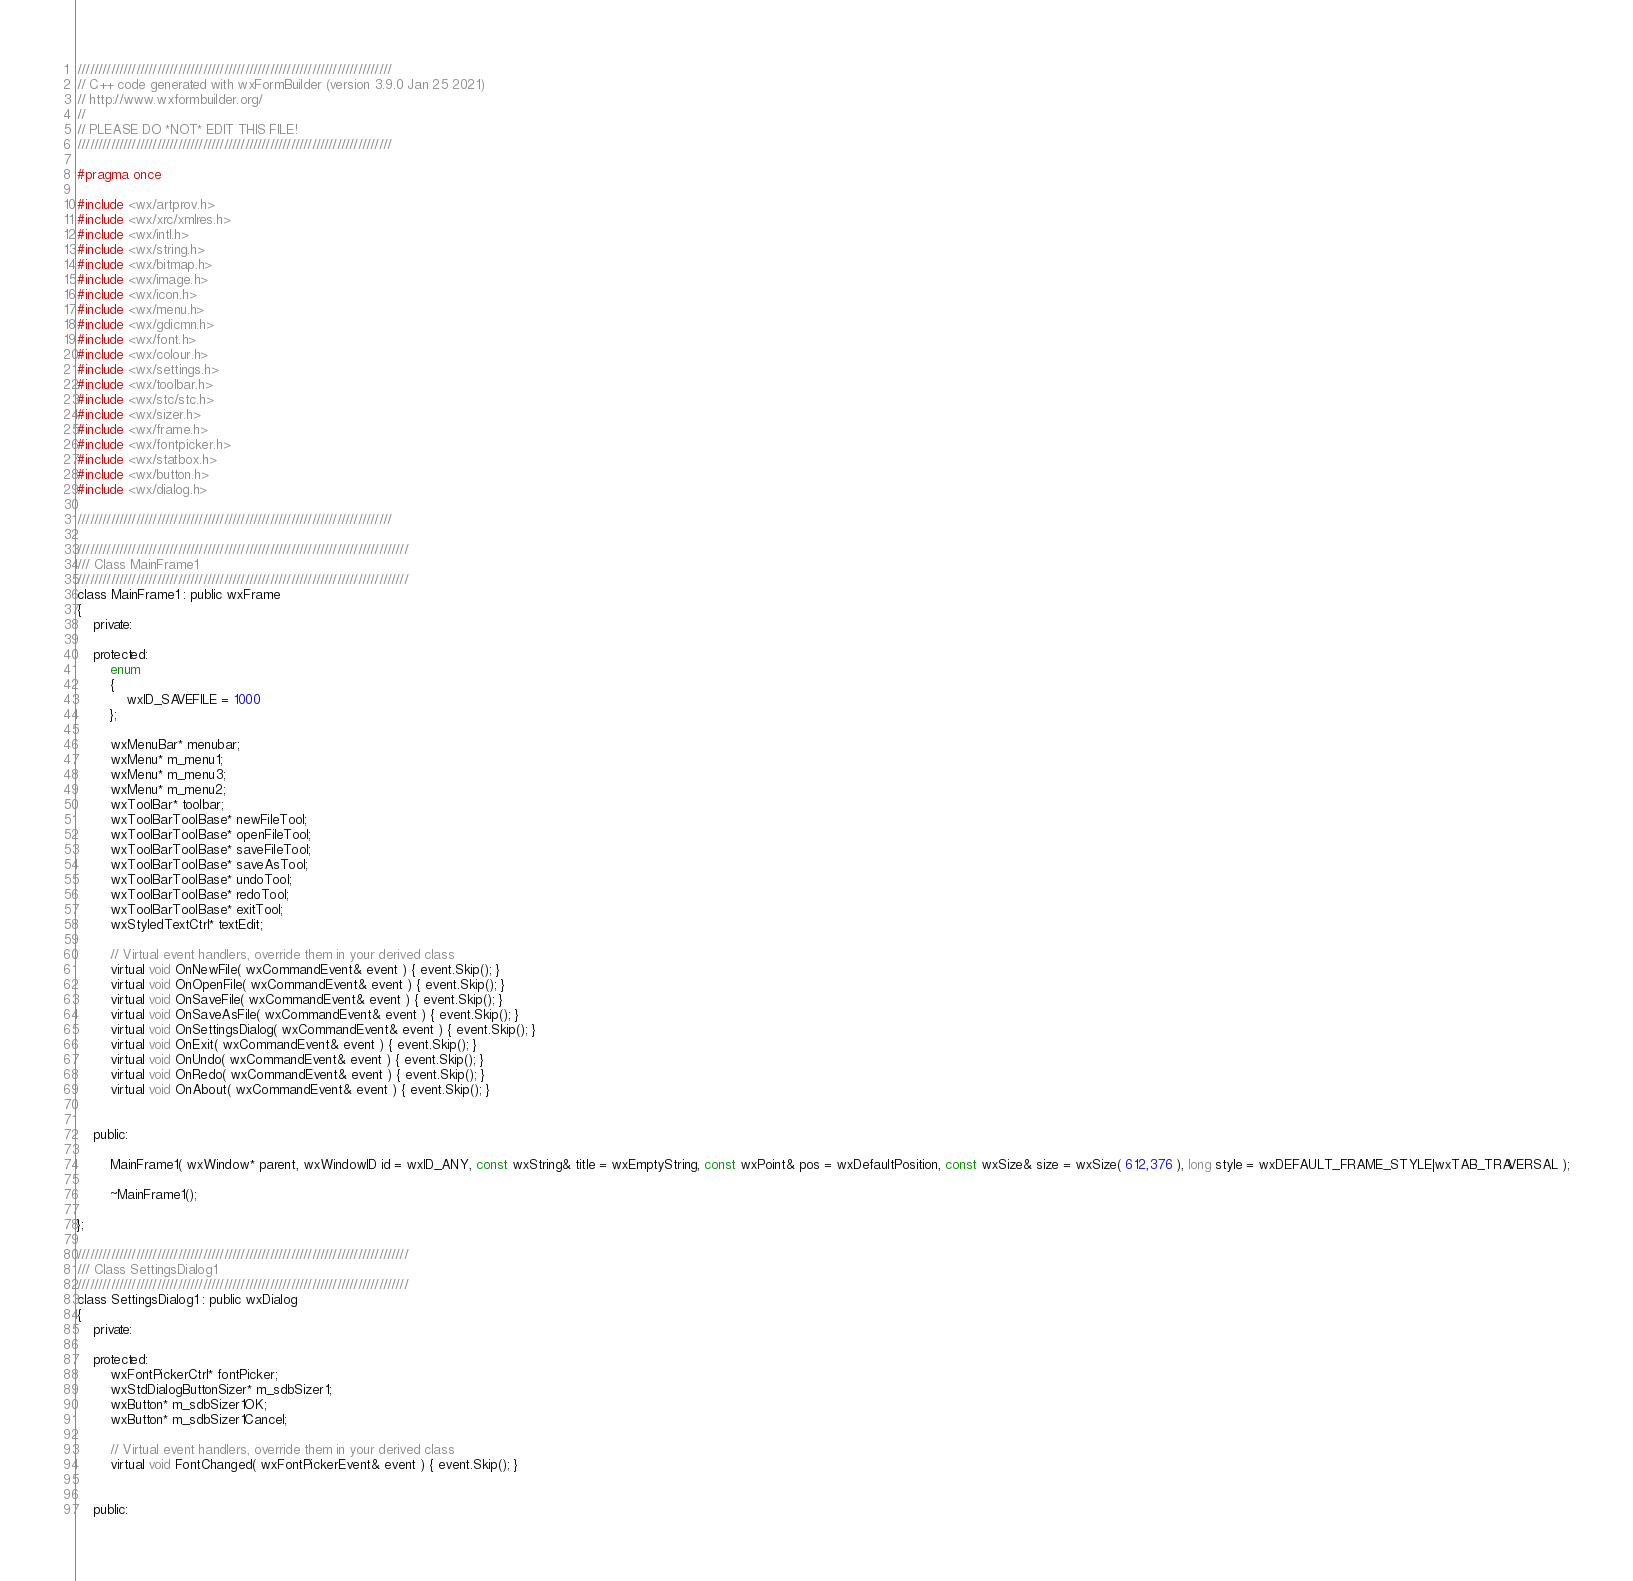Convert code to text. <code><loc_0><loc_0><loc_500><loc_500><_C_>///////////////////////////////////////////////////////////////////////////
// C++ code generated with wxFormBuilder (version 3.9.0 Jan 25 2021)
// http://www.wxformbuilder.org/
//
// PLEASE DO *NOT* EDIT THIS FILE!
///////////////////////////////////////////////////////////////////////////

#pragma once

#include <wx/artprov.h>
#include <wx/xrc/xmlres.h>
#include <wx/intl.h>
#include <wx/string.h>
#include <wx/bitmap.h>
#include <wx/image.h>
#include <wx/icon.h>
#include <wx/menu.h>
#include <wx/gdicmn.h>
#include <wx/font.h>
#include <wx/colour.h>
#include <wx/settings.h>
#include <wx/toolbar.h>
#include <wx/stc/stc.h>
#include <wx/sizer.h>
#include <wx/frame.h>
#include <wx/fontpicker.h>
#include <wx/statbox.h>
#include <wx/button.h>
#include <wx/dialog.h>

///////////////////////////////////////////////////////////////////////////

///////////////////////////////////////////////////////////////////////////////
/// Class MainFrame1
///////////////////////////////////////////////////////////////////////////////
class MainFrame1 : public wxFrame
{
	private:

	protected:
		enum
		{
			wxID_SAVEFILE = 1000
		};

		wxMenuBar* menubar;
		wxMenu* m_menu1;
		wxMenu* m_menu3;
		wxMenu* m_menu2;
		wxToolBar* toolbar;
		wxToolBarToolBase* newFileTool;
		wxToolBarToolBase* openFileTool;
		wxToolBarToolBase* saveFileTool;
		wxToolBarToolBase* saveAsTool;
		wxToolBarToolBase* undoTool;
		wxToolBarToolBase* redoTool;
		wxToolBarToolBase* exitTool;
		wxStyledTextCtrl* textEdit;

		// Virtual event handlers, override them in your derived class
		virtual void OnNewFile( wxCommandEvent& event ) { event.Skip(); }
		virtual void OnOpenFile( wxCommandEvent& event ) { event.Skip(); }
		virtual void OnSaveFile( wxCommandEvent& event ) { event.Skip(); }
		virtual void OnSaveAsFile( wxCommandEvent& event ) { event.Skip(); }
		virtual void OnSettingsDialog( wxCommandEvent& event ) { event.Skip(); }
		virtual void OnExit( wxCommandEvent& event ) { event.Skip(); }
		virtual void OnUndo( wxCommandEvent& event ) { event.Skip(); }
		virtual void OnRedo( wxCommandEvent& event ) { event.Skip(); }
		virtual void OnAbout( wxCommandEvent& event ) { event.Skip(); }


	public:

		MainFrame1( wxWindow* parent, wxWindowID id = wxID_ANY, const wxString& title = wxEmptyString, const wxPoint& pos = wxDefaultPosition, const wxSize& size = wxSize( 612,376 ), long style = wxDEFAULT_FRAME_STYLE|wxTAB_TRAVERSAL );

		~MainFrame1();

};

///////////////////////////////////////////////////////////////////////////////
/// Class SettingsDialog1
///////////////////////////////////////////////////////////////////////////////
class SettingsDialog1 : public wxDialog
{
	private:

	protected:
		wxFontPickerCtrl* fontPicker;
		wxStdDialogButtonSizer* m_sdbSizer1;
		wxButton* m_sdbSizer1OK;
		wxButton* m_sdbSizer1Cancel;

		// Virtual event handlers, override them in your derived class
		virtual void FontChanged( wxFontPickerEvent& event ) { event.Skip(); }


	public:
</code> 